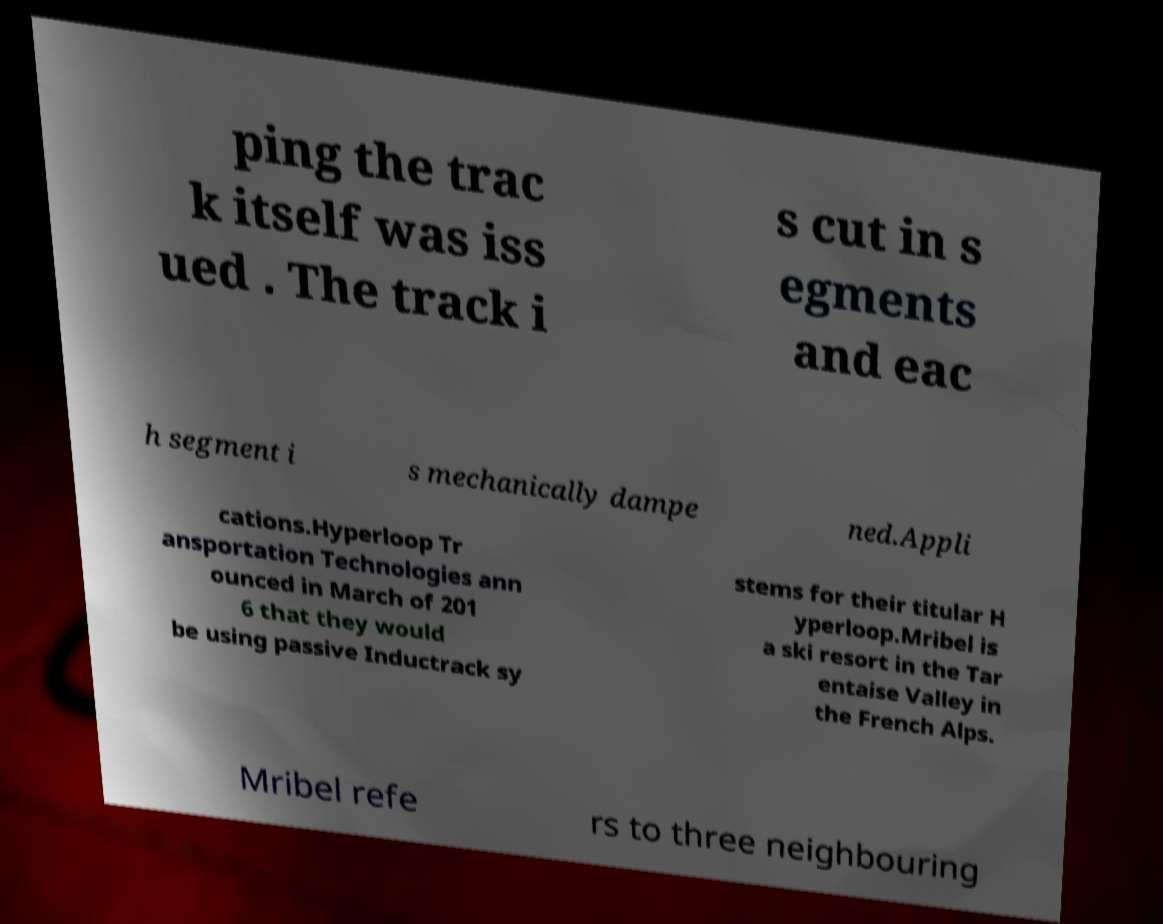Can you accurately transcribe the text from the provided image for me? ping the trac k itself was iss ued . The track i s cut in s egments and eac h segment i s mechanically dampe ned.Appli cations.Hyperloop Tr ansportation Technologies ann ounced in March of 201 6 that they would be using passive Inductrack sy stems for their titular H yperloop.Mribel is a ski resort in the Tar entaise Valley in the French Alps. Mribel refe rs to three neighbouring 